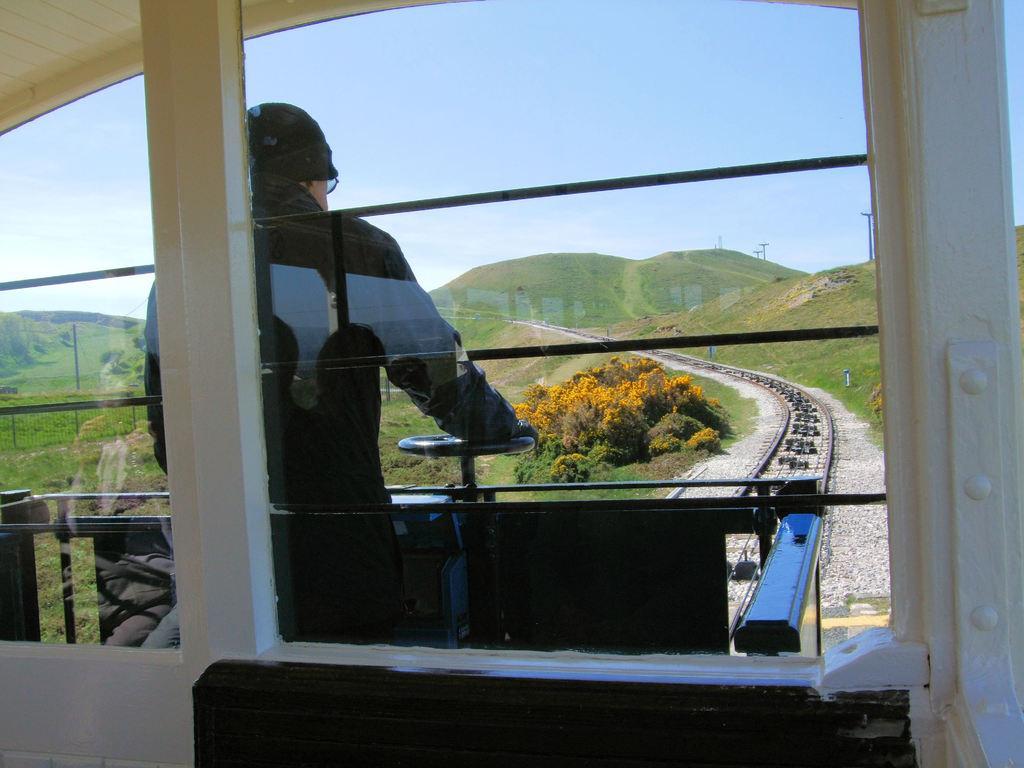Can you describe this image briefly? In the foreground of this picture we can see the vehicle seems to be the train and there is a person standing and seems to be monitoring the train. In the background we can see the sky, hills, poles, green grass, plants and the railway track and gravels. 